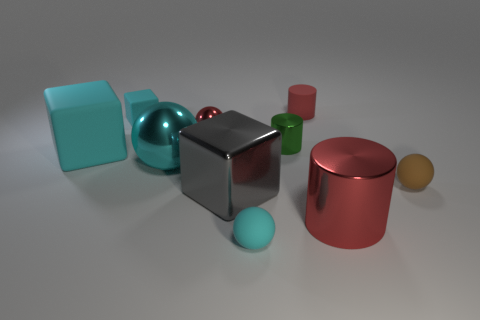How many things are big cylinders or big things that are to the left of the small green cylinder?
Provide a succinct answer. 4. Are there any small cyan things that have the same material as the red ball?
Offer a terse response. No. What number of cyan matte objects are behind the big ball and to the right of the large rubber block?
Offer a terse response. 1. What is the red thing that is in front of the brown object made of?
Make the answer very short. Metal. What is the size of the cylinder that is made of the same material as the small green object?
Provide a short and direct response. Large. There is a tiny green metallic object; are there any metal cylinders on the right side of it?
Provide a succinct answer. Yes. The brown matte object that is the same shape as the small red metallic thing is what size?
Keep it short and to the point. Small. Is the color of the large metallic block the same as the tiny object on the left side of the big metal ball?
Keep it short and to the point. No. Does the large matte thing have the same color as the tiny cube?
Provide a short and direct response. Yes. Is the number of big matte blocks less than the number of large yellow metal balls?
Provide a short and direct response. No. 